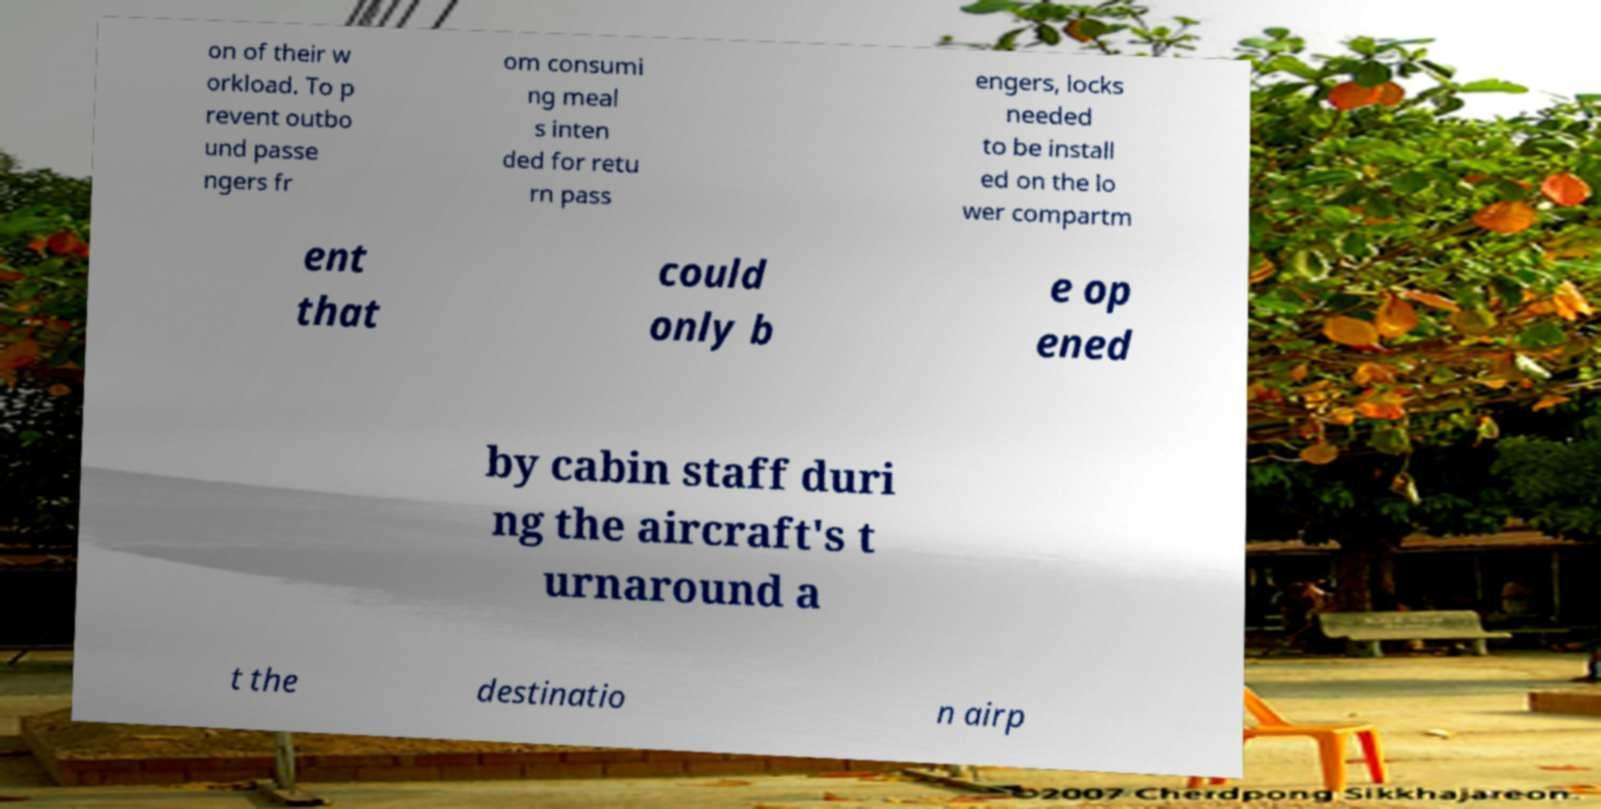Can you read and provide the text displayed in the image?This photo seems to have some interesting text. Can you extract and type it out for me? on of their w orkload. To p revent outbo und passe ngers fr om consumi ng meal s inten ded for retu rn pass engers, locks needed to be install ed on the lo wer compartm ent that could only b e op ened by cabin staff duri ng the aircraft's t urnaround a t the destinatio n airp 